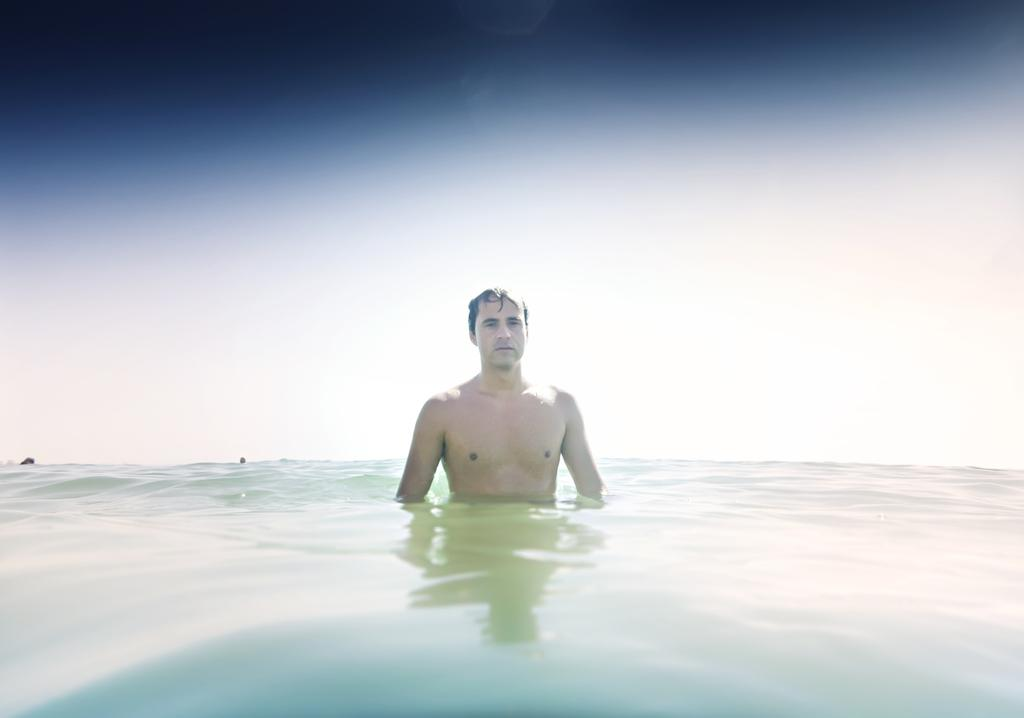What is the man in the image doing? There is a man in the water in the image. What can be seen in the background of the water? There are two objects on the water in the background. What is visible above the water in the image? The sky is visible in the image. How many pets are running on the stone in the image? There are no pets or stones present in the image. 